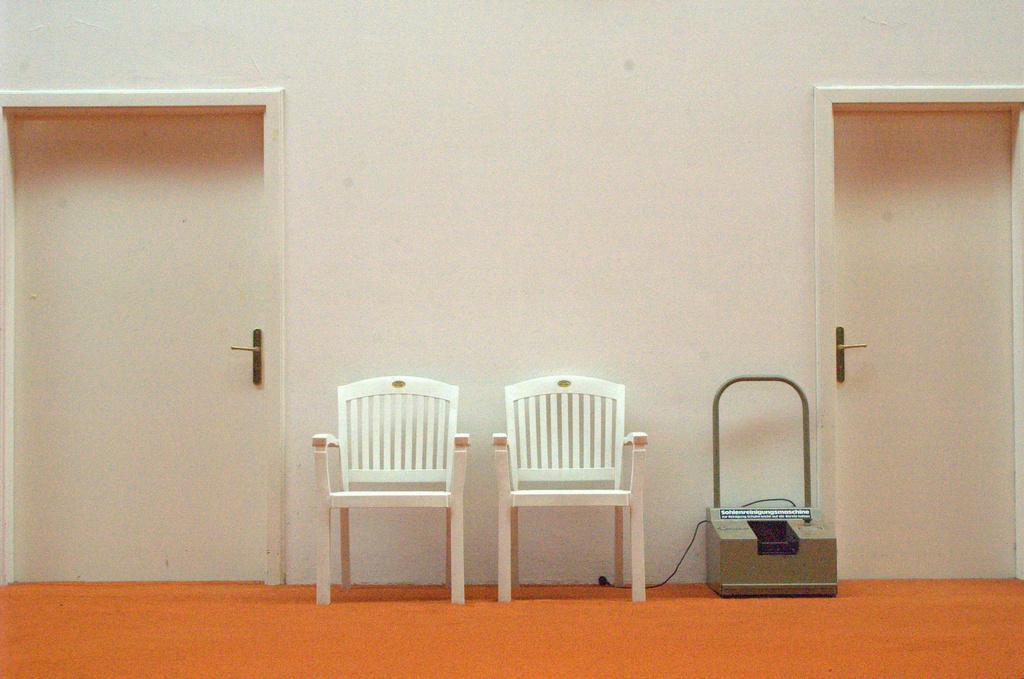Please provide a concise description of this image. This image is clicked inside the building. In the front, there are two chairs and doors. At the bottom, there is floor mat in orange color. Beside the door, there is a machine. 